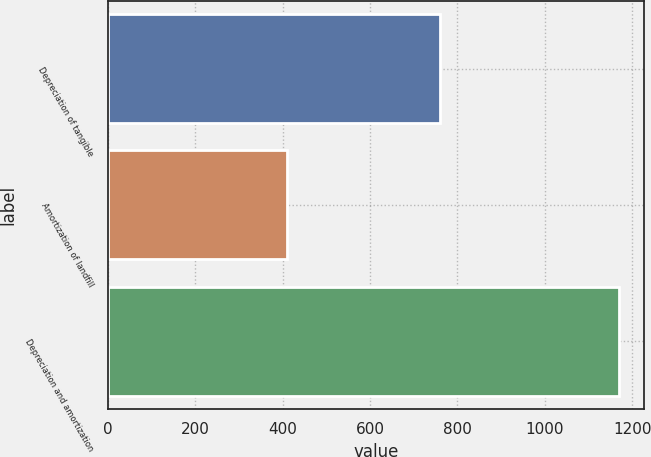Convert chart to OTSL. <chart><loc_0><loc_0><loc_500><loc_500><bar_chart><fcel>Depreciation of tangible<fcel>Amortization of landfill<fcel>Depreciation and amortization<nl><fcel>760<fcel>409<fcel>1169<nl></chart> 